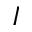<formula> <loc_0><loc_0><loc_500><loc_500>I</formula> 